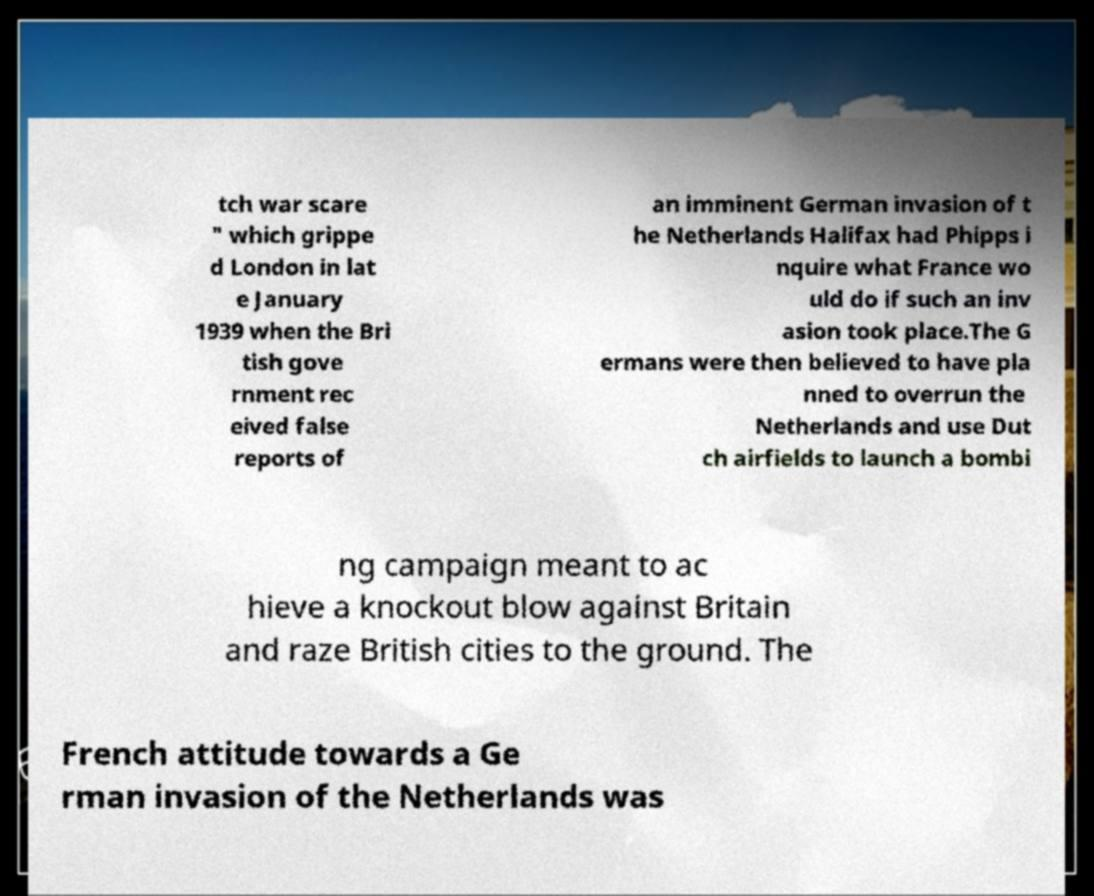Can you accurately transcribe the text from the provided image for me? tch war scare " which grippe d London in lat e January 1939 when the Bri tish gove rnment rec eived false reports of an imminent German invasion of t he Netherlands Halifax had Phipps i nquire what France wo uld do if such an inv asion took place.The G ermans were then believed to have pla nned to overrun the Netherlands and use Dut ch airfields to launch a bombi ng campaign meant to ac hieve a knockout blow against Britain and raze British cities to the ground. The French attitude towards a Ge rman invasion of the Netherlands was 